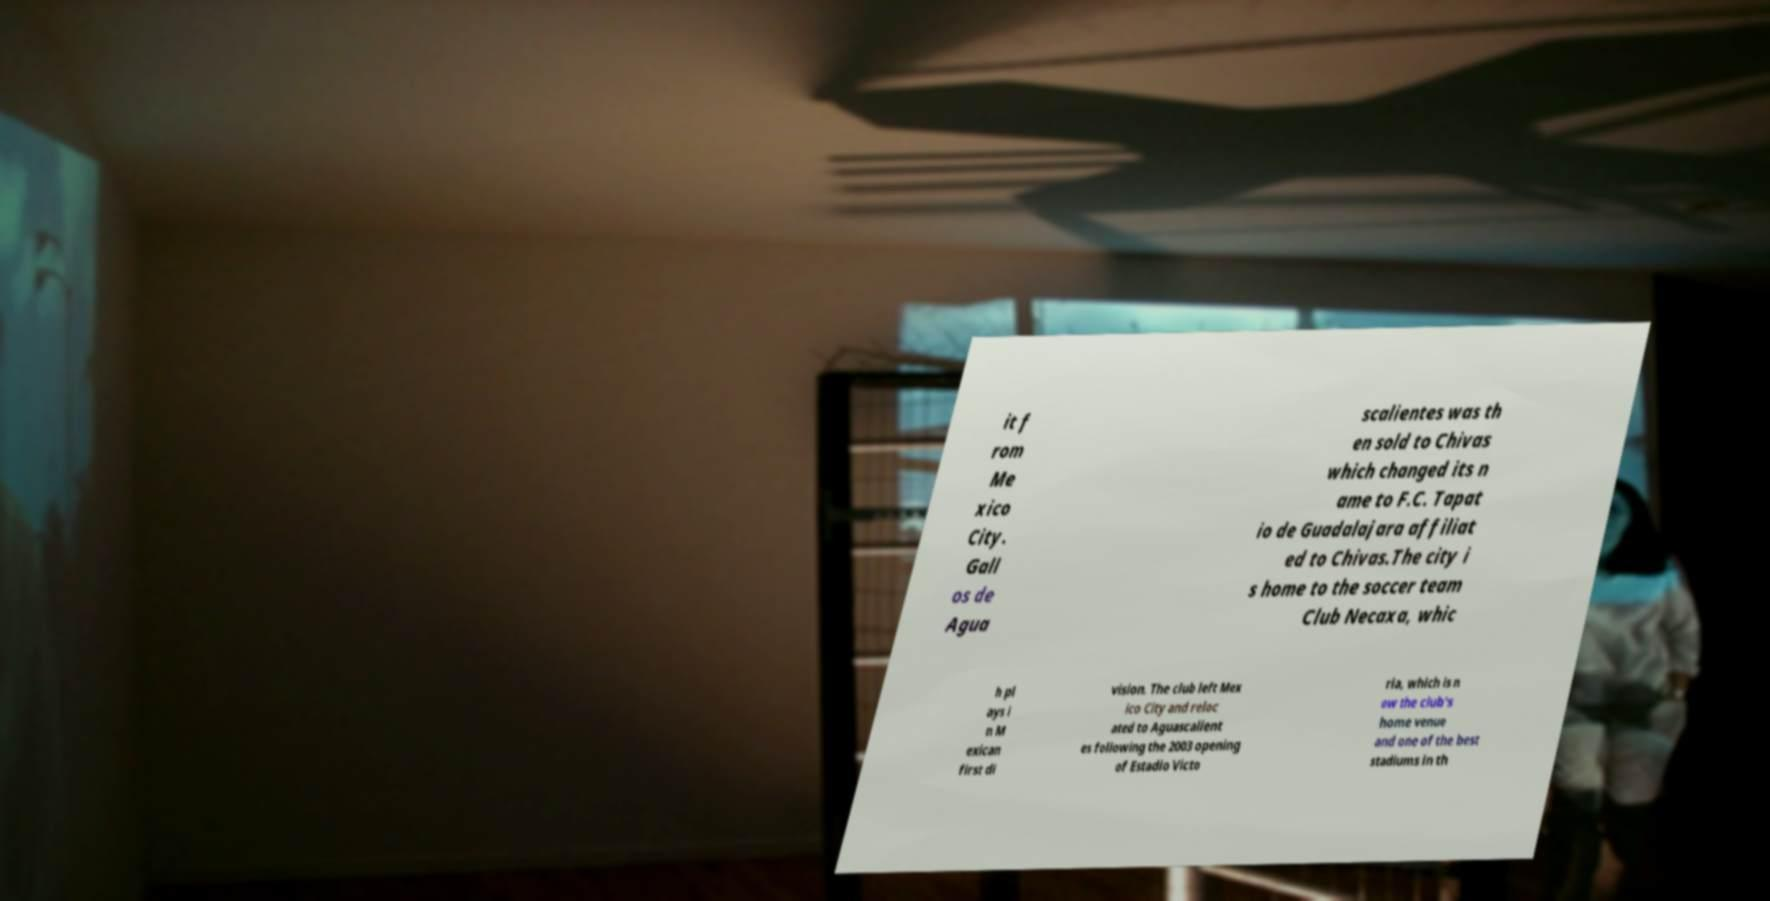Please identify and transcribe the text found in this image. it f rom Me xico City. Gall os de Agua scalientes was th en sold to Chivas which changed its n ame to F.C. Tapat io de Guadalajara affiliat ed to Chivas.The city i s home to the soccer team Club Necaxa, whic h pl ays i n M exican first di vision. The club left Mex ico City and reloc ated to Aguascalient es following the 2003 opening of Estadio Victo ria, which is n ow the club's home venue and one of the best stadiums in th 